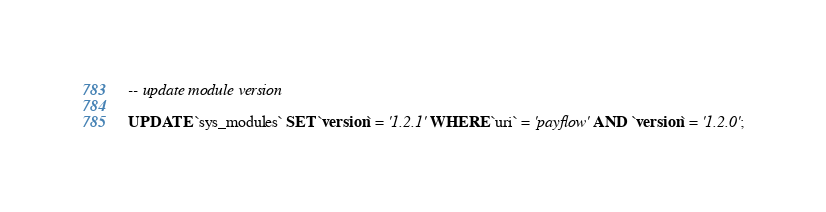Convert code to text. <code><loc_0><loc_0><loc_500><loc_500><_SQL_>

-- update module version

UPDATE `sys_modules` SET `version` = '1.2.1' WHERE `uri` = 'payflow' AND `version` = '1.2.0';

</code> 